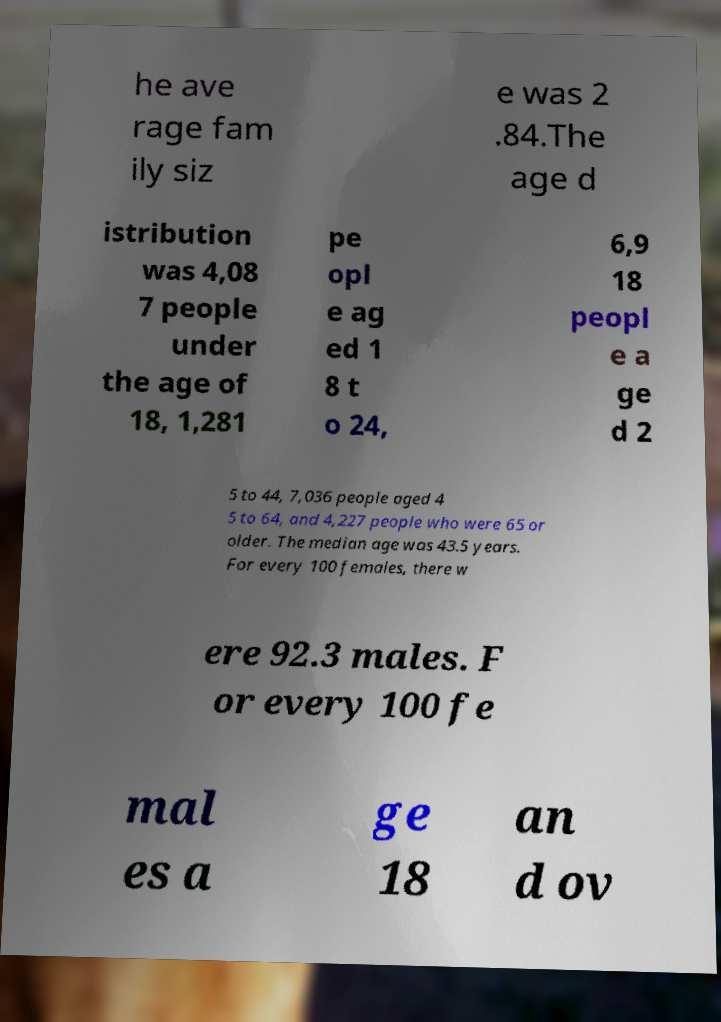Please identify and transcribe the text found in this image. he ave rage fam ily siz e was 2 .84.The age d istribution was 4,08 7 people under the age of 18, 1,281 pe opl e ag ed 1 8 t o 24, 6,9 18 peopl e a ge d 2 5 to 44, 7,036 people aged 4 5 to 64, and 4,227 people who were 65 or older. The median age was 43.5 years. For every 100 females, there w ere 92.3 males. F or every 100 fe mal es a ge 18 an d ov 